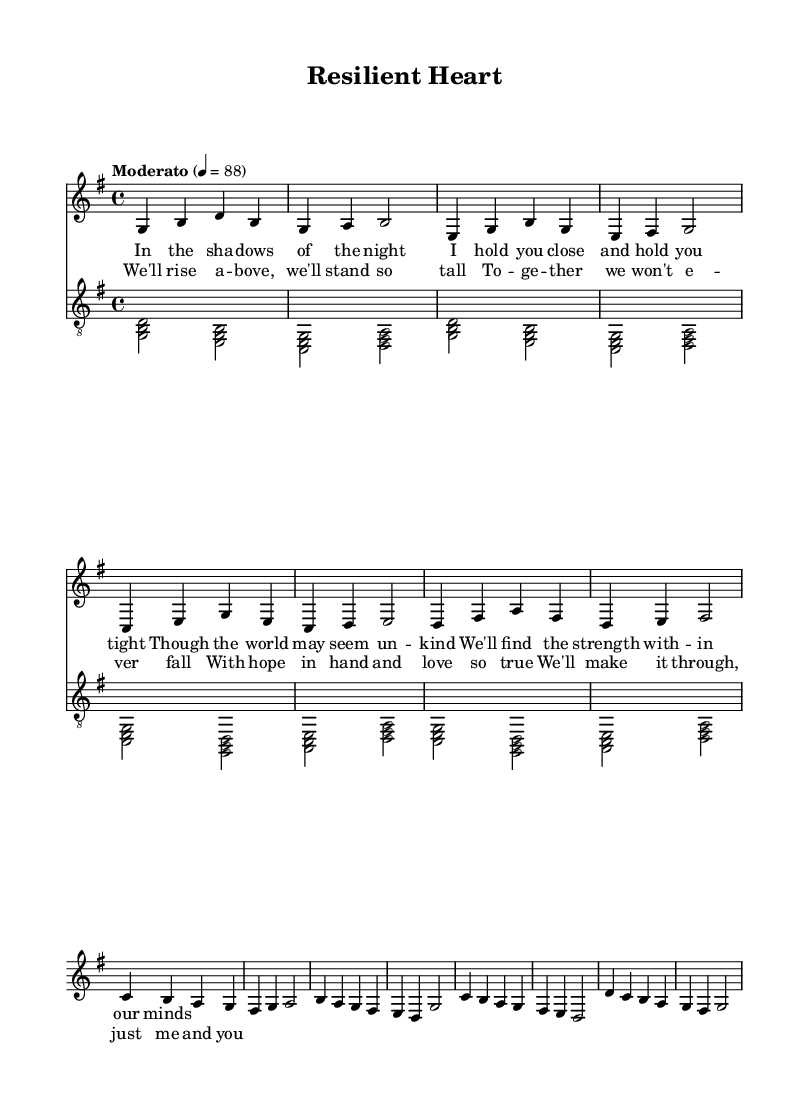What is the key signature of this music? The key signature is G major, which has one sharp (F#). This is determined by looking at the key signature at the beginning of the piece, which indicates G major.
Answer: G major What is the time signature of this music? The time signature is 4/4, indicated at the beginning of the score. This means there are four beats in each measure and the quarter note gets one beat.
Answer: 4/4 What is the tempo marking for this piece? The tempo marking is "Moderato," which indicates a moderate pace, and is usually set between 86 and 97 beats per minute. This is noted at the beginning of the score along with the metronome marking of 4 = 88.
Answer: Moderato Which section has the lyrics "We'll rise above, we'll stand so tall"? This lyric is found in the chorus section of the song. The chorus often contains the main theme or message of the song, and these specific lyrics are included in that section.
Answer: Chorus How many measures are in the verse section? The verse contains 8 measures, as counted by the individual measures separated by bar lines. Each line shows four measures, totaling to eight for the two lines of the verse.
Answer: 8 measures Identify the first chord played in the guitar part. The first chord in the guitar part is G major, represented as <g b d>. It is measured at the beginning of the guitar staff right after the time and key signatures.
Answer: G major What is the overall theme explored in the lyrics of this song? The overall theme is hope and resilience in the face of challenges, as suggested by the lyrics discussing strength, togetherness, and overcoming difficulties.
Answer: Hope and resilience 